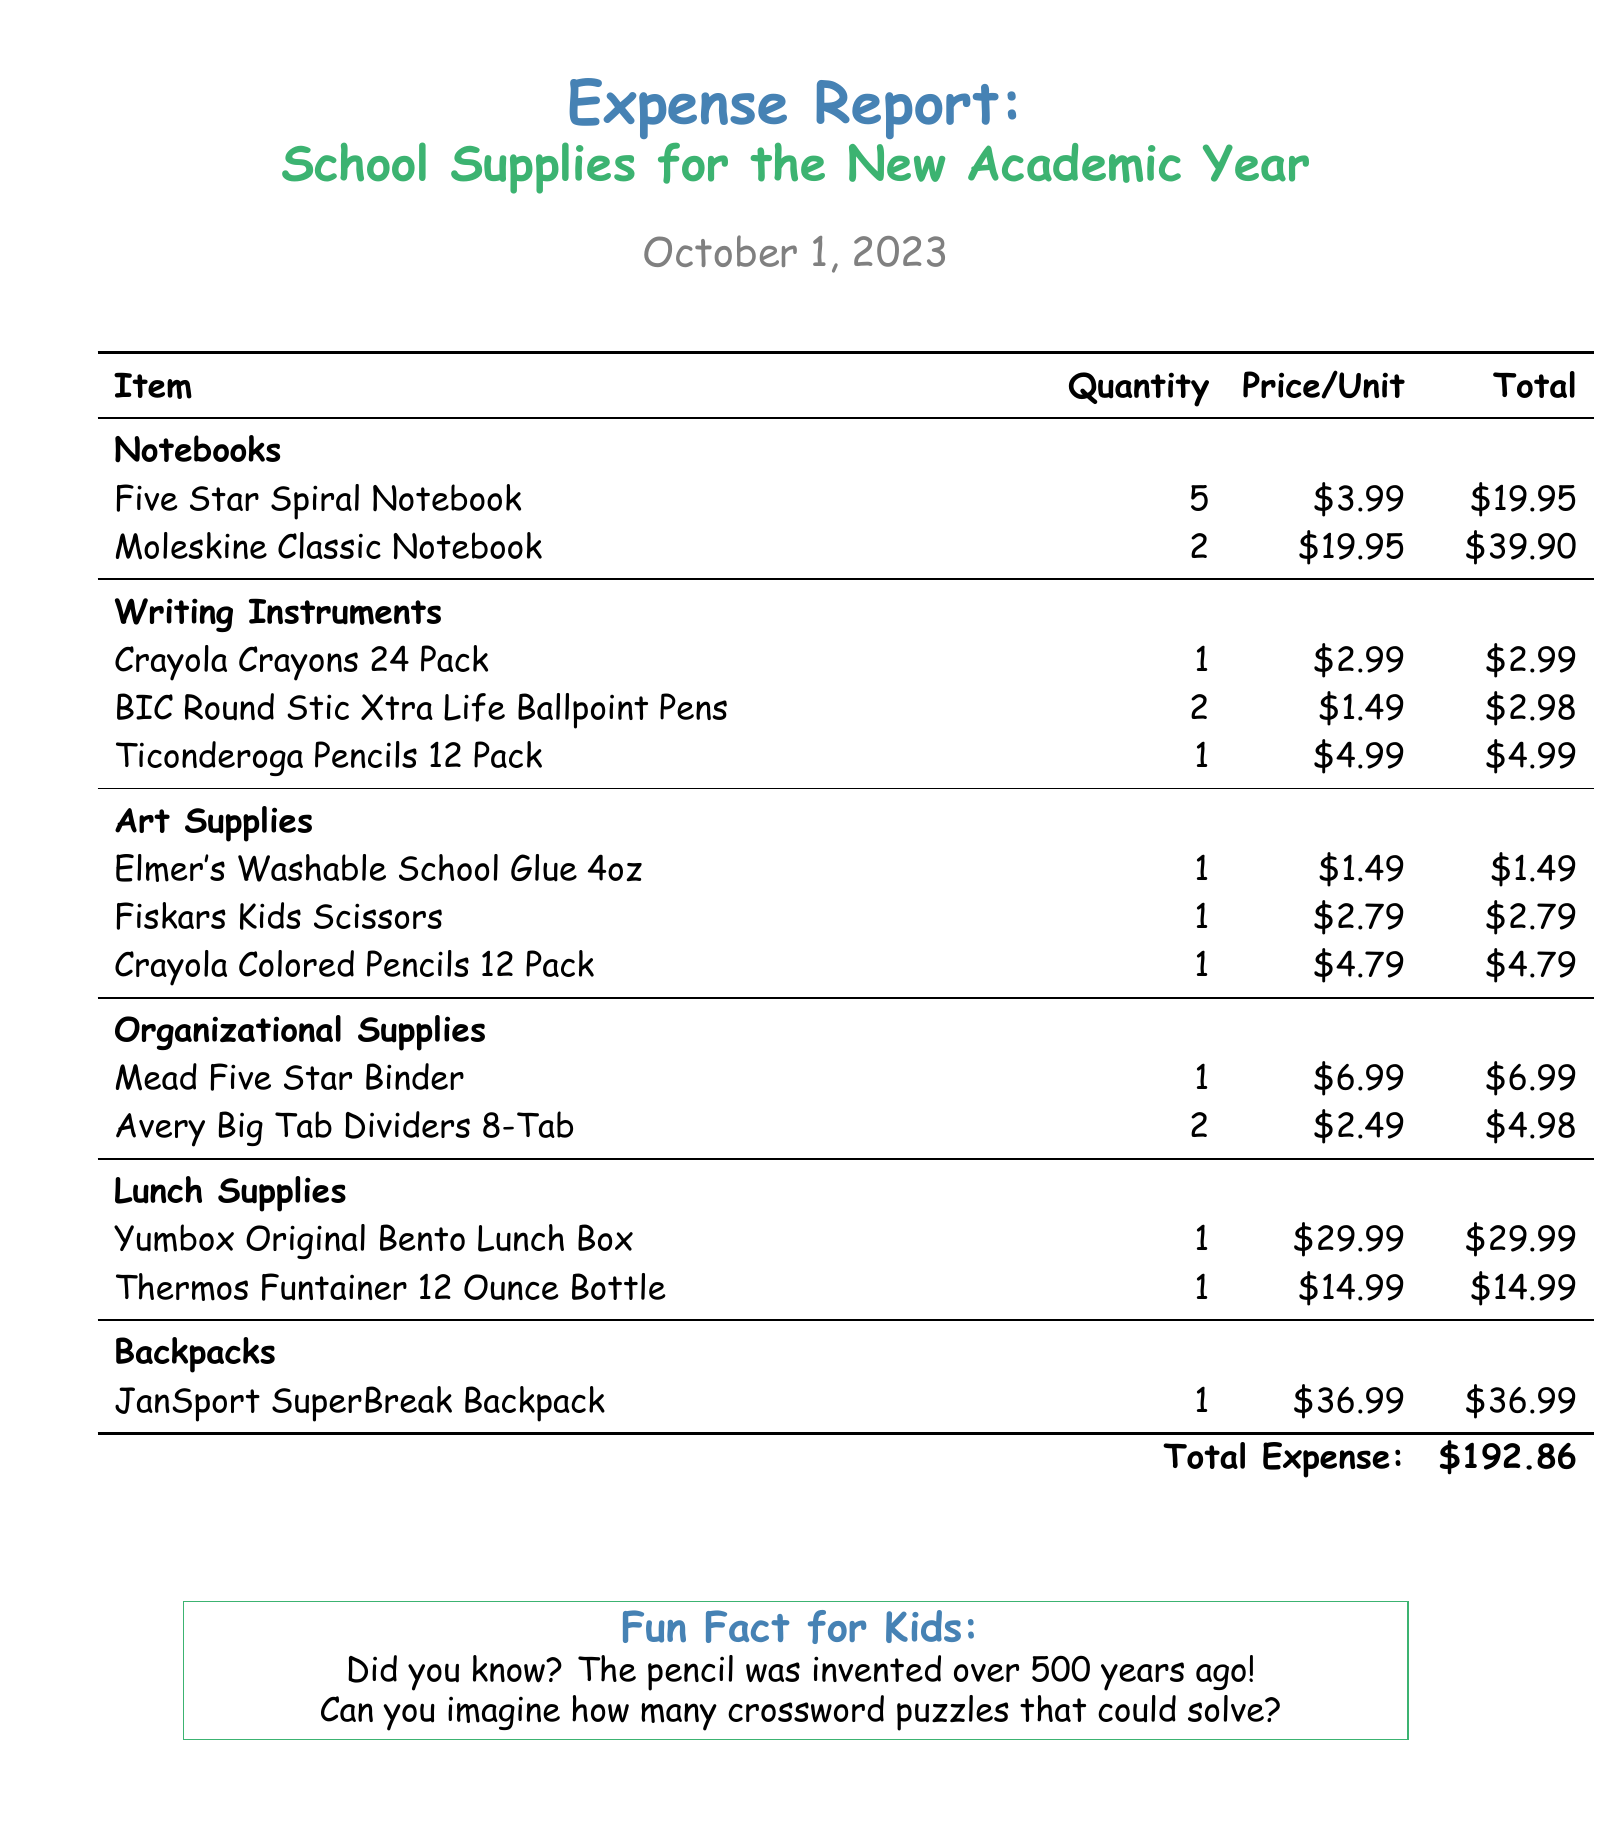What is the date of the report? The date of the report is mentioned at the top of the document as October 1, 2023.
Answer: October 1, 2023 How many Five Star Spiral Notebooks were purchased? The document lists that 5 Five Star Spiral Notebooks were bought.
Answer: 5 What is the price of the Yumbox Original Bento Lunch Box? The document specifies that the price for the Yumbox Original Bento Lunch Box is $29.99.
Answer: $29.99 How many total items are categorized under Writing Instruments? The table indicates there are 3 items (Crayola Crayons, BIC Pens, Ticonderoga Pencils) listed under Writing Instruments.
Answer: 3 What is the total expense for all school supplies? The total expense at the bottom of the document sums up all expenses to be $192.86.
Answer: $192.86 How many different types of lunch supplies are mentioned? The document lists 2 types of lunch supplies (Yumbox and Thermos).
Answer: 2 What color is used for the main title of the report? The main title is in a blue color defined as "kidblue" in the document.
Answer: kidblue What type of report is this document? The document is an expense report specifically for school supplies.
Answer: Expense report 